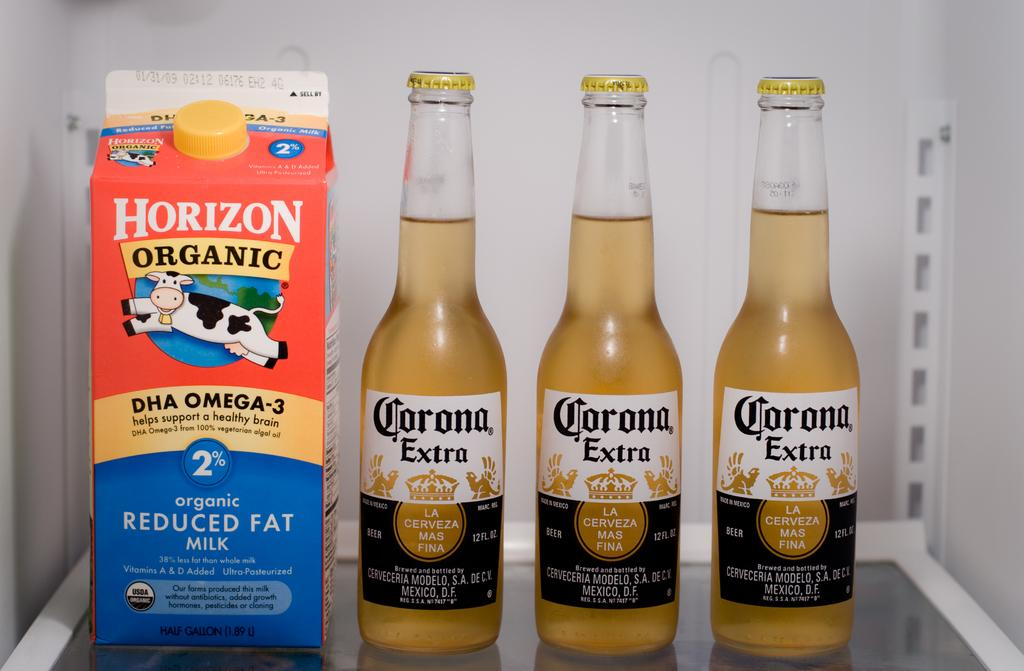<image>
Share a concise interpretation of the image provided. A refrigerator contains a carton of Horizon Organic milk and three bottles of Corona Extra. 